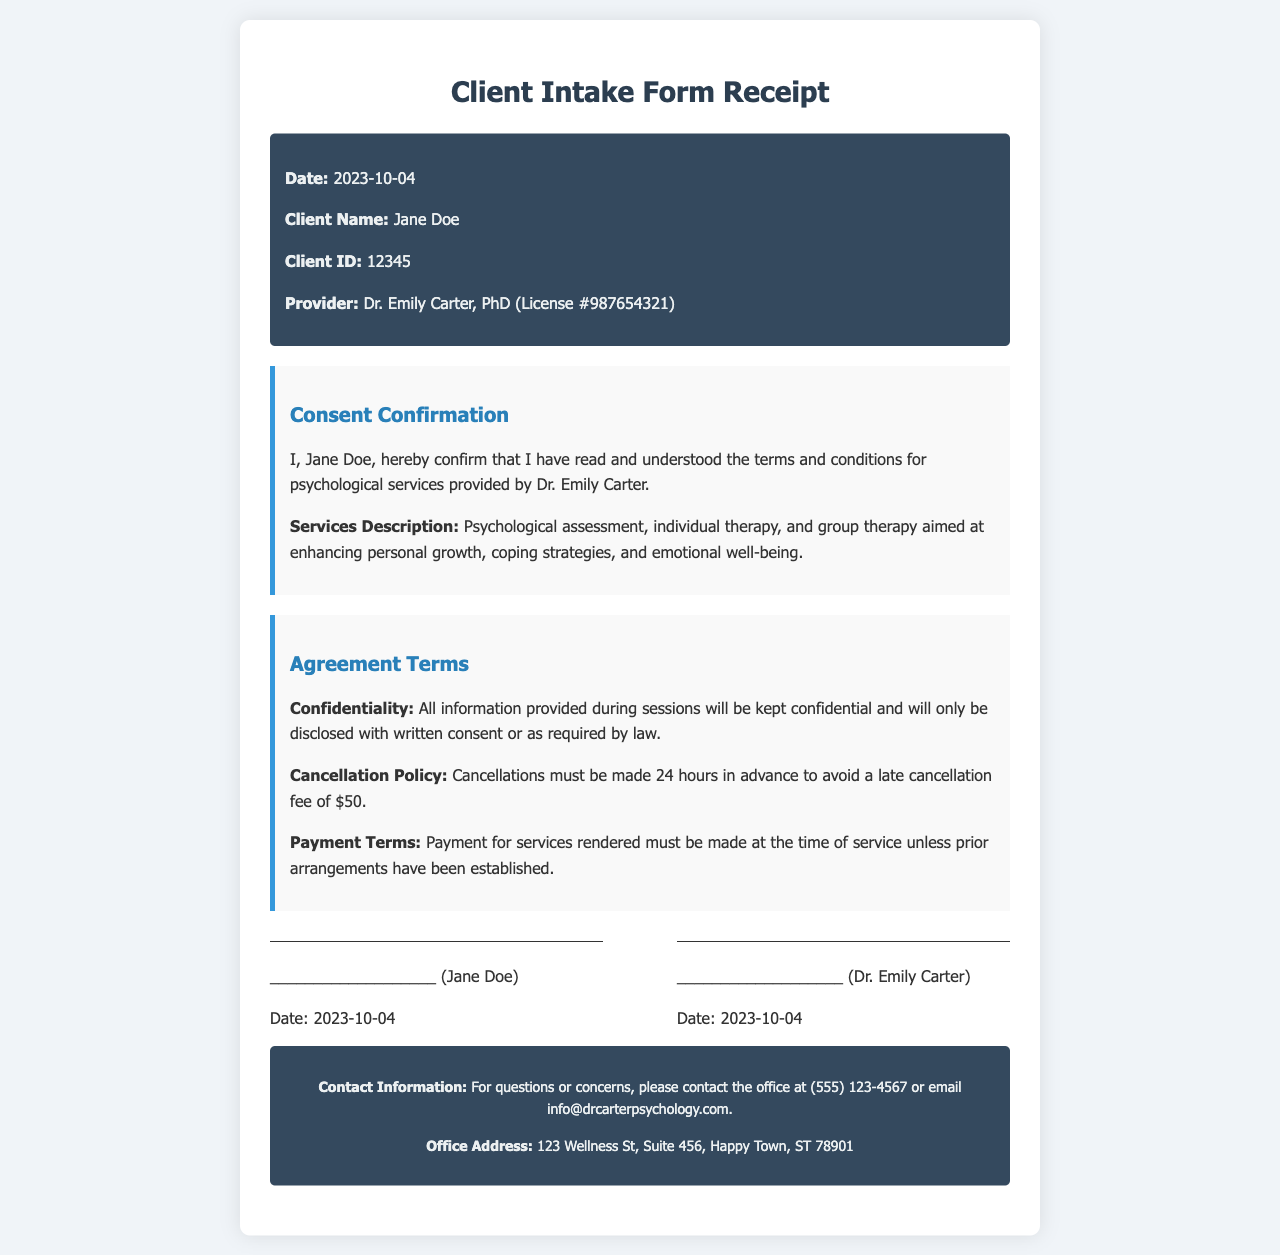What is the date of the receipt? The date of the receipt is located at the top of the document under the header section.
Answer: 2023-10-04 What is the name of the client? The client's name is specified in the header section of the document.
Answer: Jane Doe Who is the provider of the psychological services? The name of the provider can be found in the header, alongside their qualifications.
Answer: Dr. Emily Carter, PhD What is the client ID number? The client ID number is mentioned in the header of the document.
Answer: 12345 What is the cancellation policy? The cancellation policy is listed under the Agreement Terms section of the document.
Answer: Cancellations must be made 24 hours in advance to avoid a late cancellation fee of $50 What types of services are described in the document? The types of services can be found in the Consent Confirmation section, detailing the nature of the services provided.
Answer: Psychological assessment, individual therapy, and group therapy What is stated about confidentiality? The confidentiality clause is outlined in the Agreement Terms section of the document.
Answer: All information provided during sessions will be kept confidential What is the office phone number? The contact information section at the bottom of the document contains the office phone number.
Answer: (555) 123-4567 What must be done to avoid a late cancellation fee? This is indicated under the Agreement Terms section discussing the cancellation policy.
Answer: Cancellations must be made 24 hours in advance 